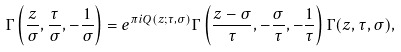<formula> <loc_0><loc_0><loc_500><loc_500>\Gamma \left ( \frac { z } { \sigma } , \frac { \tau } { \sigma } , - \frac { 1 } { \sigma } \right ) = e ^ { \pi i Q ( z ; \tau , \sigma ) } \Gamma \left ( \frac { z - \sigma } { \tau } , - \frac { \sigma } { \tau } , - \frac { 1 } { \tau } \right ) \Gamma ( z , \tau , \sigma ) ,</formula> 